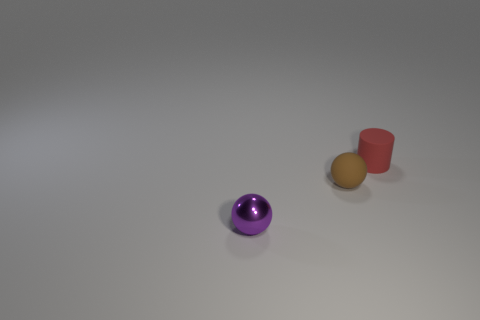Add 3 tiny red metal objects. How many objects exist? 6 Subtract all cylinders. How many objects are left? 2 Subtract 0 cyan spheres. How many objects are left? 3 Subtract all red matte objects. Subtract all small purple spheres. How many objects are left? 1 Add 3 tiny red cylinders. How many tiny red cylinders are left? 4 Add 3 purple spheres. How many purple spheres exist? 4 